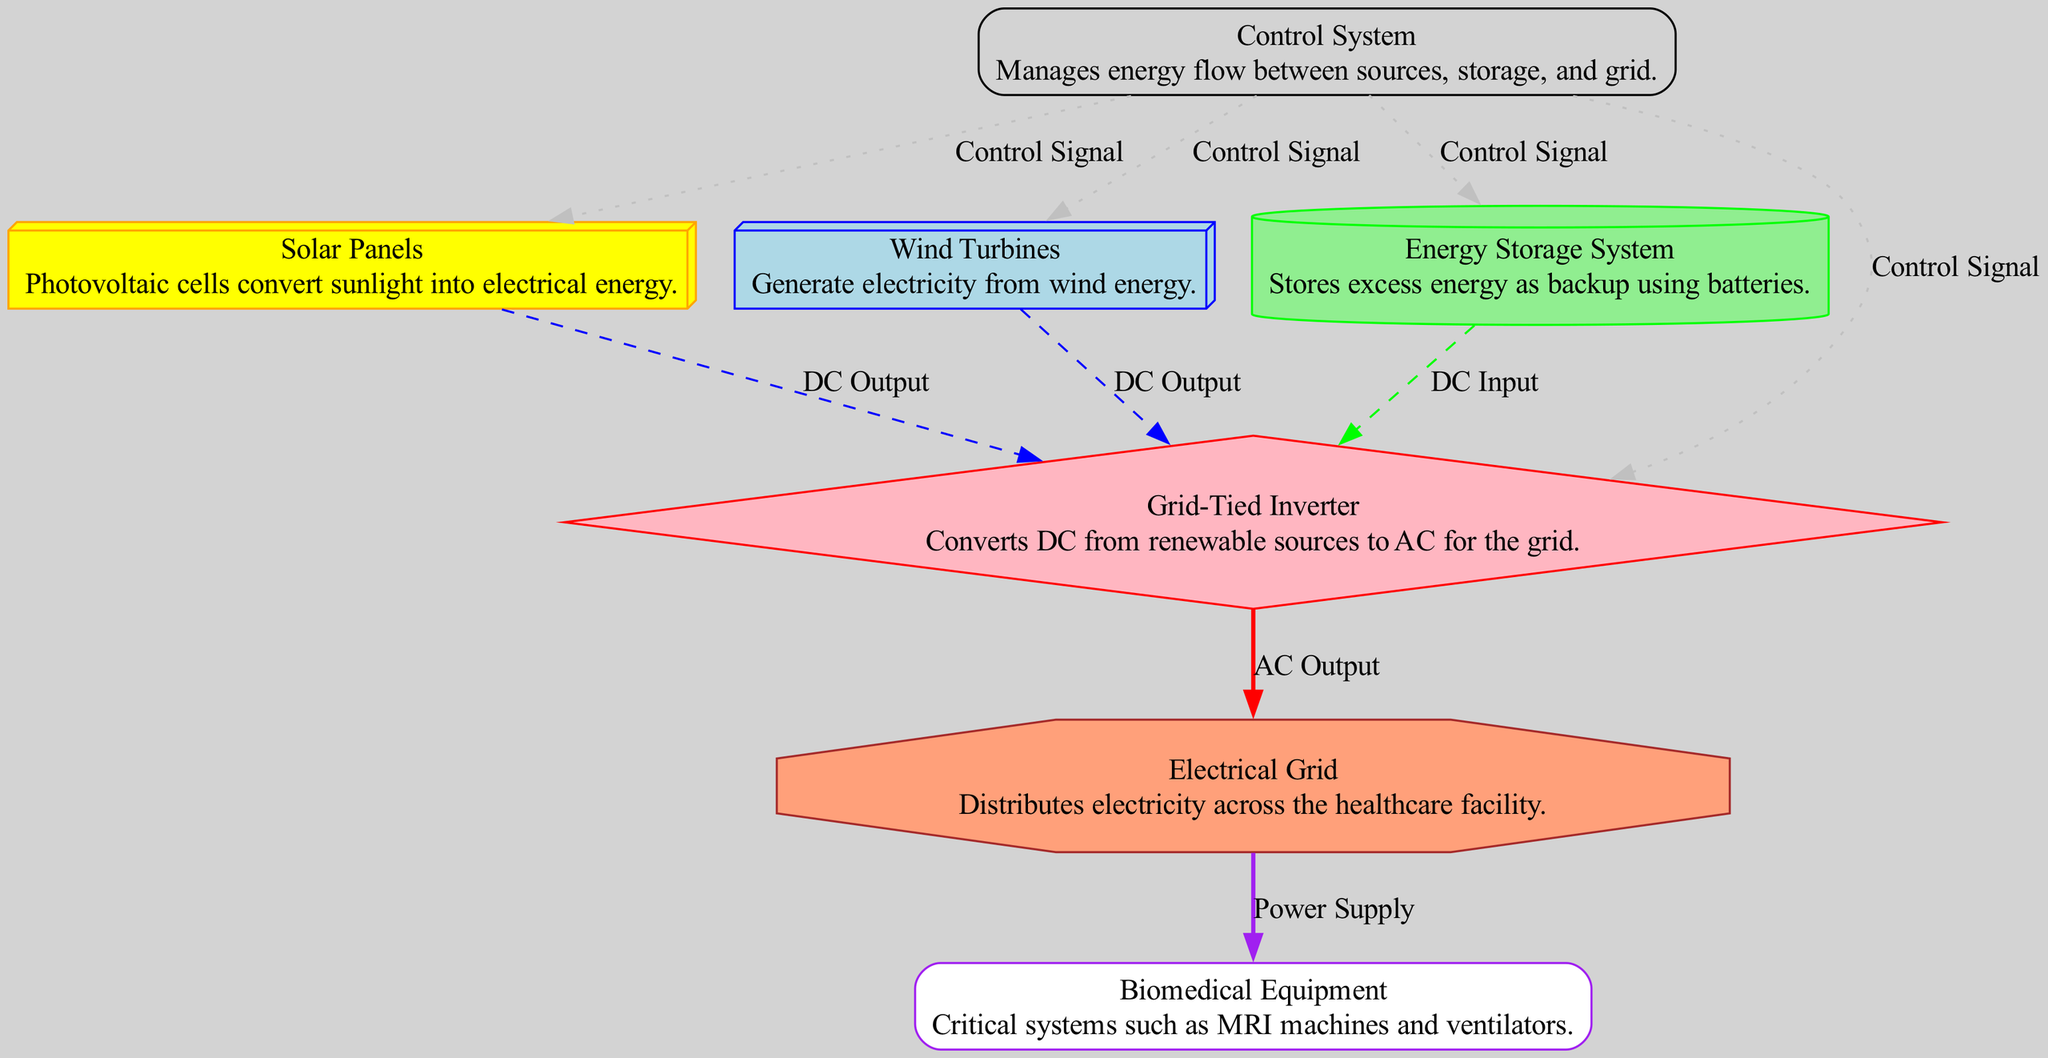What are the two types of energy sources in the diagram? The diagram includes solar panels and wind turbines, which are both renewable sources of energy.
Answer: solar panels, wind turbines How many nodes are there in total? The diagram has a total of 8 nodes, which include solar panels, wind turbines, energy storage system, grid-tied inverter, electrical grid, control system, and biomedical equipment.
Answer: 8 Which node outputs AC to the electrical grid? The grid-tied inverter converts the DC from renewable sources into AC, which is output to the electrical grid.
Answer: Grid-Tied Inverter What type of signal does the control system send to the energy storage system? The control system sends control signals to various nodes including the energy storage system, which helps manage energy flow effectively.
Answer: Control Signal Which components supply power to biomedical equipment? The electrical grid distributes power to biomedical equipment, enabling critical healthcare systems to function properly.
Answer: Electrical Grid What inputs does the grid-tied inverter receive? The grid-tied inverter receives DC inputs from solar panels, wind turbines, and the energy storage system, which it then converts to AC.
Answer: Solar Panels, Wind Turbines, Energy Storage System How does the energy storage system interact with the grid-tied inverter? The energy storage system provides DC input to the grid-tied inverter which then converts this energy into AC for distribution through the electrical grid.
Answer: DC Input Which system manages the flow of energy between components? The control system is responsible for managing the energy flow between renewable sources, the storage system, and the grid, ensuring proper operation.
Answer: Control System 